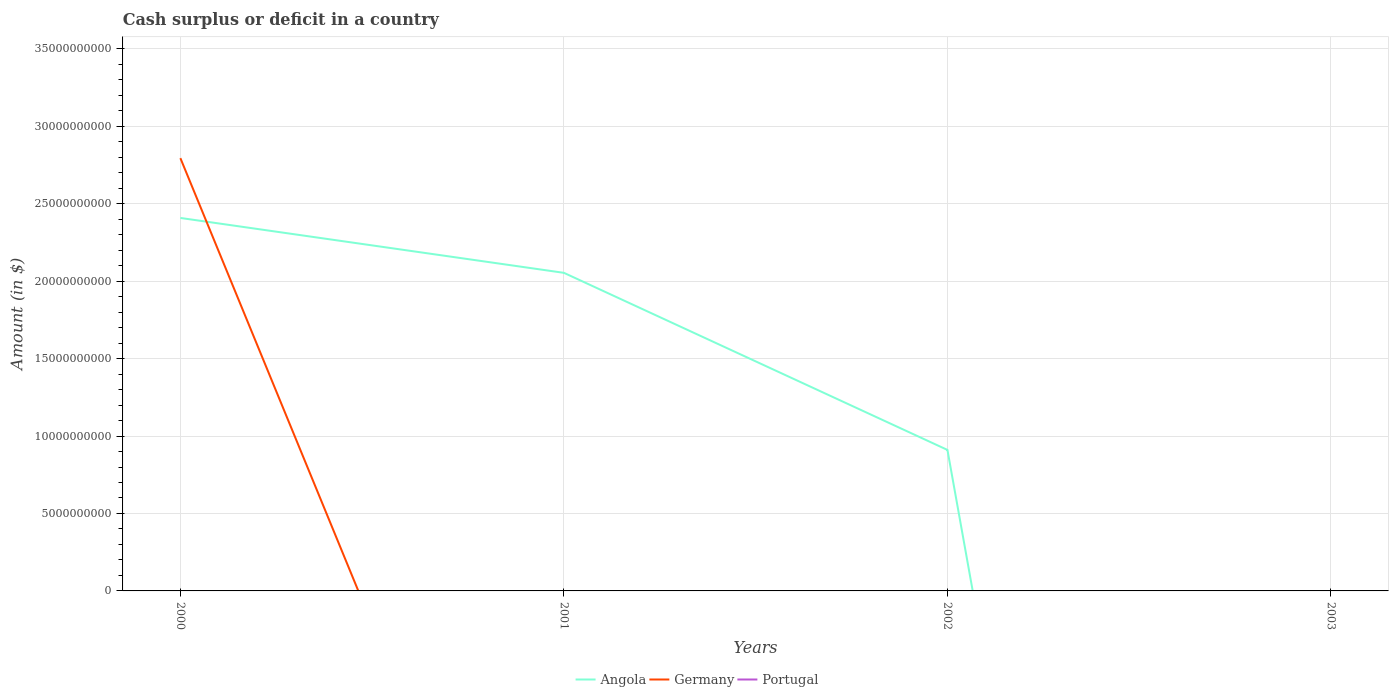How many different coloured lines are there?
Offer a very short reply. 2. Does the line corresponding to Portugal intersect with the line corresponding to Germany?
Your answer should be very brief. Yes. Across all years, what is the maximum amount of cash surplus or deficit in Portugal?
Ensure brevity in your answer.  0. What is the total amount of cash surplus or deficit in Angola in the graph?
Ensure brevity in your answer.  1.14e+1. What is the difference between the highest and the second highest amount of cash surplus or deficit in Germany?
Your answer should be very brief. 2.79e+1. Is the amount of cash surplus or deficit in Portugal strictly greater than the amount of cash surplus or deficit in Germany over the years?
Offer a very short reply. No. How many lines are there?
Your answer should be compact. 2. How many years are there in the graph?
Offer a very short reply. 4. Are the values on the major ticks of Y-axis written in scientific E-notation?
Keep it short and to the point. No. Does the graph contain grids?
Keep it short and to the point. Yes. How many legend labels are there?
Your answer should be very brief. 3. How are the legend labels stacked?
Give a very brief answer. Horizontal. What is the title of the graph?
Your answer should be compact. Cash surplus or deficit in a country. What is the label or title of the Y-axis?
Keep it short and to the point. Amount (in $). What is the Amount (in $) of Angola in 2000?
Your answer should be compact. 2.41e+1. What is the Amount (in $) in Germany in 2000?
Provide a short and direct response. 2.79e+1. What is the Amount (in $) in Portugal in 2000?
Your answer should be very brief. 0. What is the Amount (in $) of Angola in 2001?
Make the answer very short. 2.05e+1. What is the Amount (in $) of Germany in 2001?
Offer a very short reply. 0. What is the Amount (in $) in Portugal in 2001?
Offer a terse response. 0. What is the Amount (in $) of Angola in 2002?
Your answer should be compact. 9.10e+09. What is the Amount (in $) of Portugal in 2002?
Ensure brevity in your answer.  0. What is the Amount (in $) in Portugal in 2003?
Your response must be concise. 0. Across all years, what is the maximum Amount (in $) of Angola?
Your answer should be compact. 2.41e+1. Across all years, what is the maximum Amount (in $) of Germany?
Provide a short and direct response. 2.79e+1. Across all years, what is the minimum Amount (in $) of Angola?
Ensure brevity in your answer.  0. Across all years, what is the minimum Amount (in $) of Germany?
Offer a very short reply. 0. What is the total Amount (in $) of Angola in the graph?
Your response must be concise. 5.37e+1. What is the total Amount (in $) in Germany in the graph?
Make the answer very short. 2.79e+1. What is the total Amount (in $) of Portugal in the graph?
Your answer should be very brief. 0. What is the difference between the Amount (in $) of Angola in 2000 and that in 2001?
Offer a very short reply. 3.54e+09. What is the difference between the Amount (in $) of Angola in 2000 and that in 2002?
Your response must be concise. 1.50e+1. What is the difference between the Amount (in $) in Angola in 2001 and that in 2002?
Give a very brief answer. 1.14e+1. What is the average Amount (in $) of Angola per year?
Your answer should be very brief. 1.34e+1. What is the average Amount (in $) of Germany per year?
Give a very brief answer. 6.98e+09. What is the average Amount (in $) of Portugal per year?
Your answer should be compact. 0. In the year 2000, what is the difference between the Amount (in $) in Angola and Amount (in $) in Germany?
Make the answer very short. -3.86e+09. What is the ratio of the Amount (in $) of Angola in 2000 to that in 2001?
Provide a short and direct response. 1.17. What is the ratio of the Amount (in $) in Angola in 2000 to that in 2002?
Your answer should be compact. 2.65. What is the ratio of the Amount (in $) in Angola in 2001 to that in 2002?
Provide a short and direct response. 2.26. What is the difference between the highest and the second highest Amount (in $) of Angola?
Keep it short and to the point. 3.54e+09. What is the difference between the highest and the lowest Amount (in $) of Angola?
Give a very brief answer. 2.41e+1. What is the difference between the highest and the lowest Amount (in $) of Germany?
Your response must be concise. 2.79e+1. 